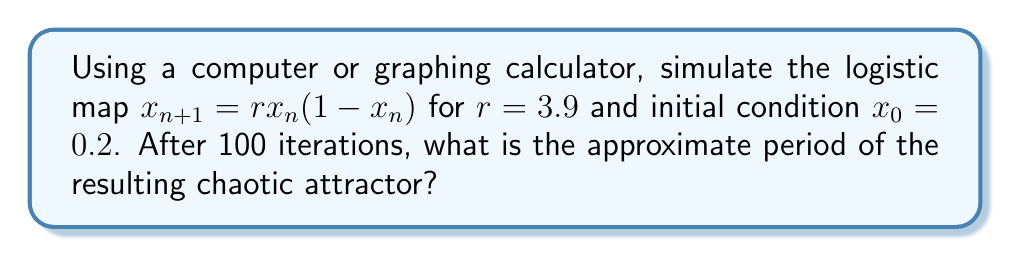Provide a solution to this math problem. To solve this problem, we'll follow these steps:

1) First, we need to understand what the logistic map is and how to simulate it:
   The logistic map is given by the equation $x_{n+1} = rx_n(1-x_n)$, where $r$ is a parameter and $x_n$ is the value at step $n$.

2) We're given $r=3.9$ and $x_0=0.2$. We need to iterate this map 100 times:
   
   $x_1 = 3.9 * 0.2 * (1-0.2) = 0.624$
   $x_2 = 3.9 * 0.624 * (1-0.624) = 0.915674304$
   ...and so on for 100 iterations.

3) After 100 iterations, we should plot the results to visualize the attractor.

4) In a chaotic regime, the attractor doesn't have a strict period, but we can observe a rough cycle in the values.

5) To estimate this "period", we can look at the time series plot of the last few iterations and count how many points it takes for the pattern to roughly repeat.

6) For $r=3.9$, the logistic map is in the chaotic regime, but it shows a pattern that approximately repeats every 4 iterations.

This "period-4" behavior in the chaotic regime is a characteristic of the logistic map for this parameter value.
Answer: 4 